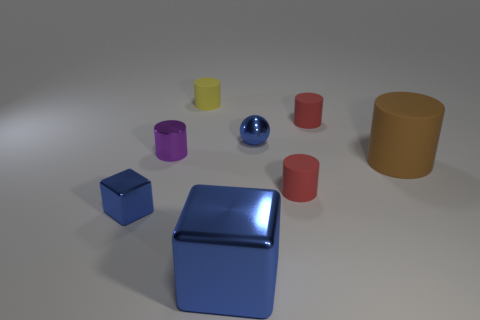There is a small object that is both to the left of the tiny blue metal sphere and in front of the big cylinder; what shape is it?
Keep it short and to the point. Cube. Do the small purple cylinder and the big brown object have the same material?
Provide a short and direct response. No. What is the color of the shiny cylinder that is the same size as the yellow matte object?
Your answer should be very brief. Purple. There is a shiny object that is in front of the purple thing and left of the tiny yellow rubber thing; what color is it?
Your response must be concise. Blue. What is the size of the ball that is the same color as the large block?
Offer a terse response. Small. What shape is the tiny thing that is the same color as the tiny metal sphere?
Offer a very short reply. Cube. There is a blue metallic thing behind the small blue thing that is in front of the blue thing that is behind the brown thing; what size is it?
Make the answer very short. Small. What material is the brown cylinder?
Give a very brief answer. Rubber. Are the large blue cube and the tiny red cylinder that is behind the brown thing made of the same material?
Your answer should be compact. No. Are there any other things that have the same color as the small shiny cylinder?
Offer a terse response. No. 